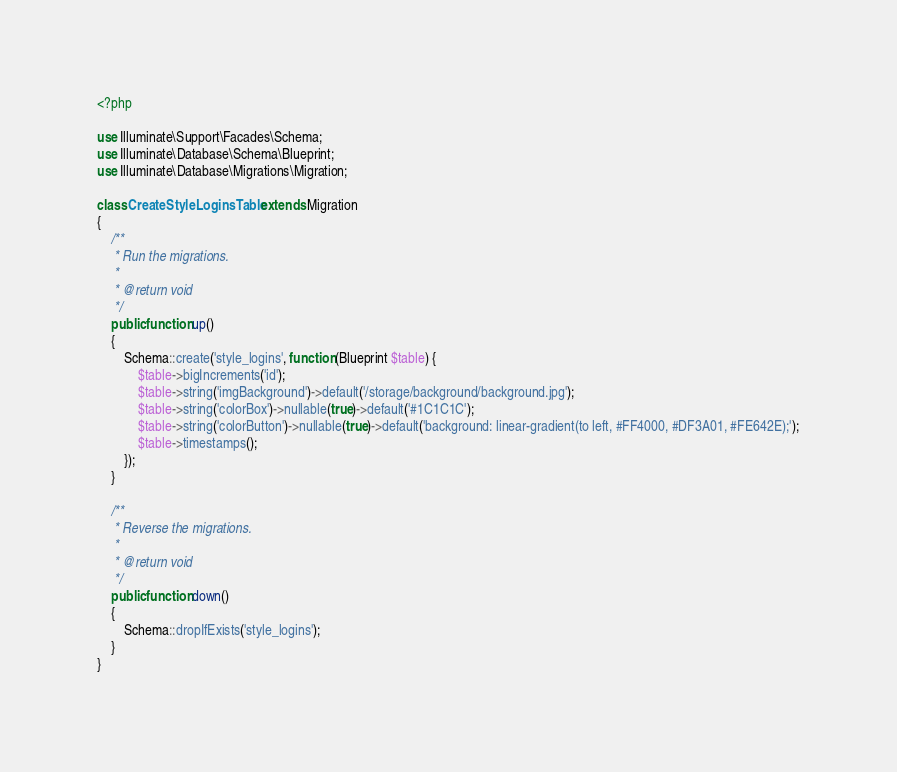<code> <loc_0><loc_0><loc_500><loc_500><_PHP_><?php

use Illuminate\Support\Facades\Schema;
use Illuminate\Database\Schema\Blueprint;
use Illuminate\Database\Migrations\Migration;

class CreateStyleLoginsTable extends Migration
{
    /**
     * Run the migrations.
     *
     * @return void
     */
    public function up()
    {
        Schema::create('style_logins', function (Blueprint $table) {
            $table->bigIncrements('id');
            $table->string('imgBackground')->default('/storage/background/background.jpg');
            $table->string('colorBox')->nullable(true)->default('#1C1C1C');
            $table->string('colorButton')->nullable(true)->default('background: linear-gradient(to left, #FF4000, #DF3A01, #FE642E);');
            $table->timestamps();
        });
    }

    /**
     * Reverse the migrations.
     *
     * @return void
     */
    public function down()
    {
        Schema::dropIfExists('style_logins');
    }
}
</code> 